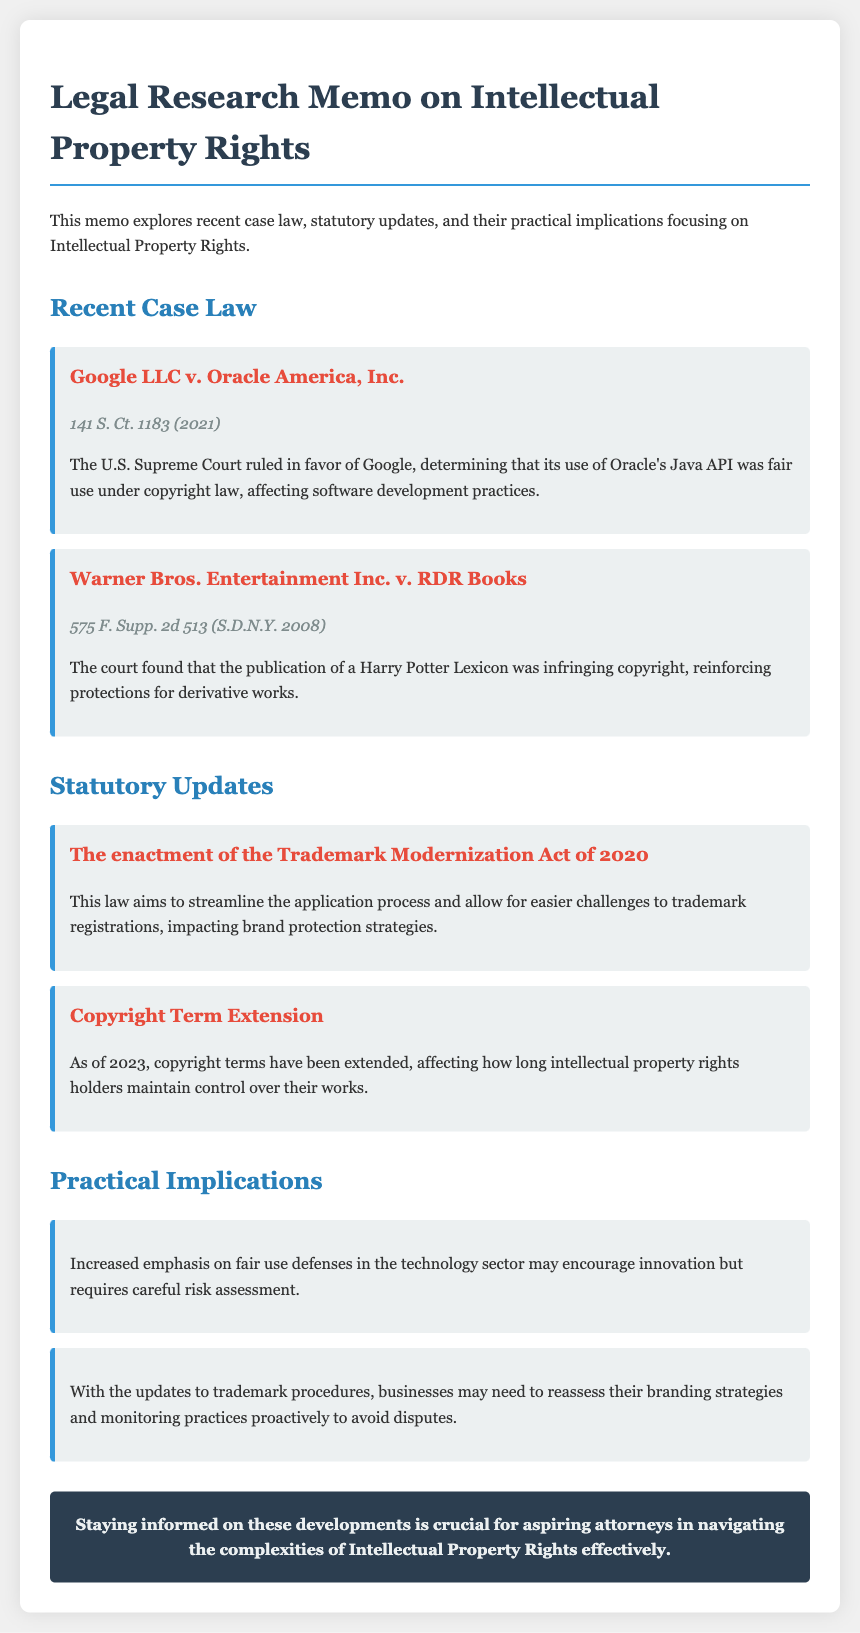what is the title of the document? The title is prominently displayed at the top of the document, clearly stating the subject matter.
Answer: Legal Research Memo on Intellectual Property Rights who was the plaintiff in Google LLC v. Oracle America, Inc.? The plaintiff is identified in the case heading as the first party mentioned.
Answer: Oracle America, Inc when was the Google LLC v. Oracle America, Inc. decision made? The citation includes the year when the case was decided, which is part of the case reference.
Answer: 2021 what is the purpose of the Trademark Modernization Act of 2020? The document describes the main aim of the act in the update section, summarizing its objectives succinctly.
Answer: Streamline the application process how does the court view the publication of the Harry Potter Lexicon? The document provides a straightforward interpretation of the court's ruling concerning the publication.
Answer: Infringing copyright what potential effect does fair use have in the technology sector? The implications section outlines the potential outcome of this legal concept, showing its relevance.
Answer: Encourage innovation which section discusses the practical implications for businesses? The section title directly indicates the content address, indicating the relevant aspects.
Answer: Practical Implications how has copyright terms changed as of 2023? The update section states what has occurred regarding copyright terms, shaping rights holders' control.
Answer: Extended 